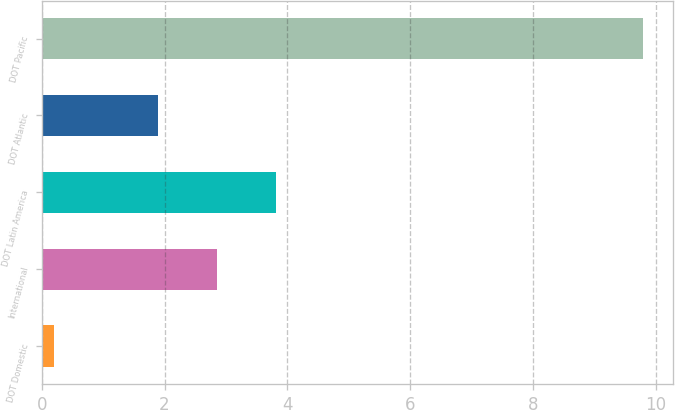Convert chart to OTSL. <chart><loc_0><loc_0><loc_500><loc_500><bar_chart><fcel>DOT Domestic<fcel>International<fcel>DOT Latin America<fcel>DOT Atlantic<fcel>DOT Pacific<nl><fcel>0.2<fcel>2.86<fcel>3.82<fcel>1.9<fcel>9.8<nl></chart> 